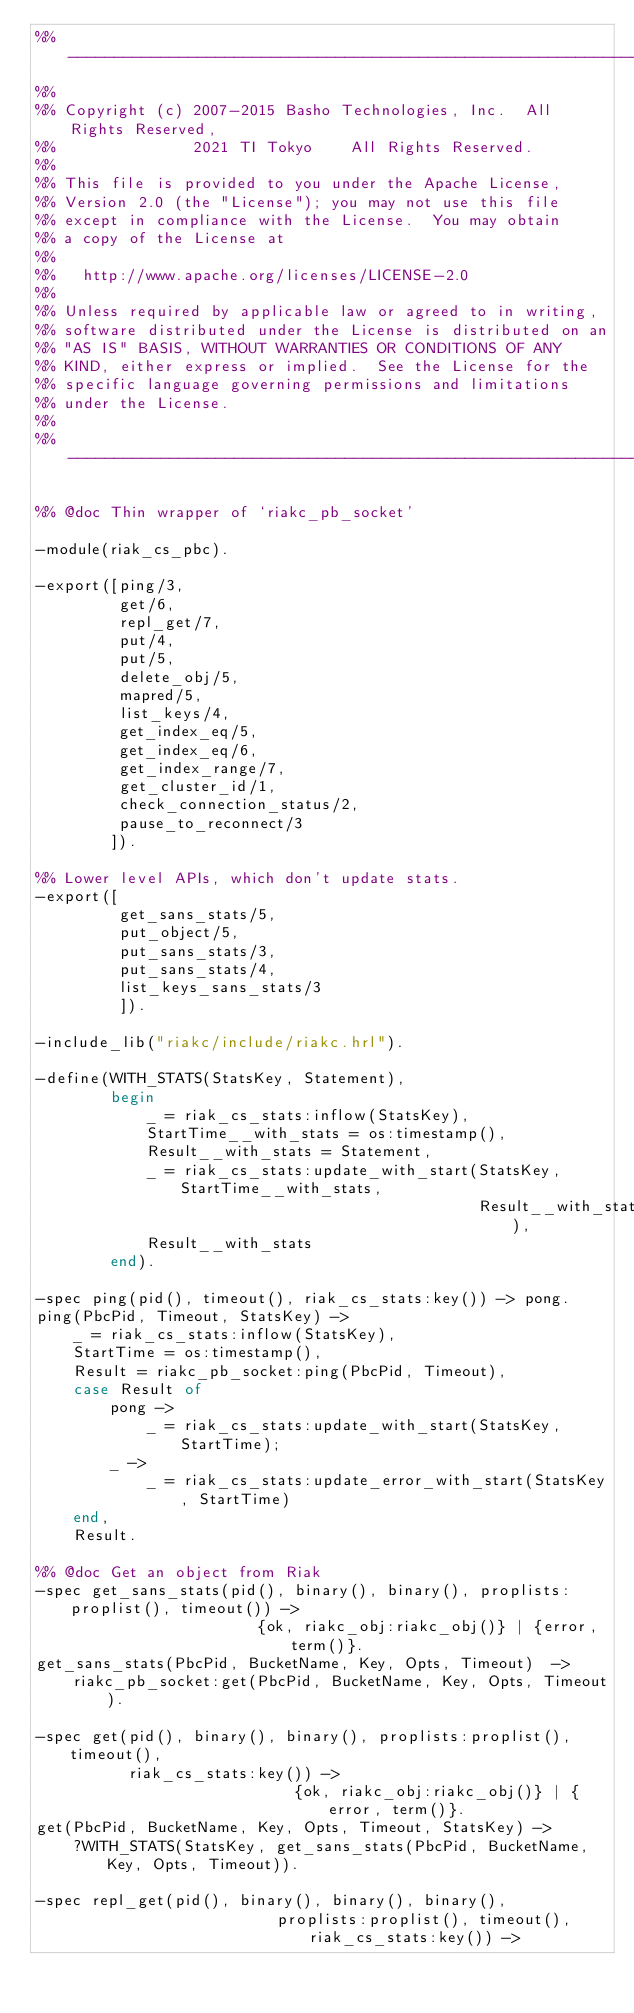Convert code to text. <code><loc_0><loc_0><loc_500><loc_500><_Erlang_>%% ---------------------------------------------------------------------
%%
%% Copyright (c) 2007-2015 Basho Technologies, Inc.  All Rights Reserved,
%%               2021 TI Tokyo    All Rights Reserved.
%%
%% This file is provided to you under the Apache License,
%% Version 2.0 (the "License"); you may not use this file
%% except in compliance with the License.  You may obtain
%% a copy of the License at
%%
%%   http://www.apache.org/licenses/LICENSE-2.0
%%
%% Unless required by applicable law or agreed to in writing,
%% software distributed under the License is distributed on an
%% "AS IS" BASIS, WITHOUT WARRANTIES OR CONDITIONS OF ANY
%% KIND, either express or implied.  See the License for the
%% specific language governing permissions and limitations
%% under the License.
%%
%% ---------------------------------------------------------------------

%% @doc Thin wrapper of `riakc_pb_socket'

-module(riak_cs_pbc).

-export([ping/3,
         get/6,
         repl_get/7,
         put/4,
         put/5,
         delete_obj/5,
         mapred/5,
         list_keys/4,
         get_index_eq/5,
         get_index_eq/6,
         get_index_range/7,
         get_cluster_id/1,
         check_connection_status/2,
         pause_to_reconnect/3
        ]).

%% Lower level APIs, which don't update stats.
-export([
         get_sans_stats/5,
         put_object/5,
         put_sans_stats/3,
         put_sans_stats/4,
         list_keys_sans_stats/3
         ]).

-include_lib("riakc/include/riakc.hrl").

-define(WITH_STATS(StatsKey, Statement),
        begin
            _ = riak_cs_stats:inflow(StatsKey),
            StartTime__with_stats = os:timestamp(),
            Result__with_stats = Statement,
            _ = riak_cs_stats:update_with_start(StatsKey, StartTime__with_stats,
                                                Result__with_stats),
            Result__with_stats
        end).

-spec ping(pid(), timeout(), riak_cs_stats:key()) -> pong.
ping(PbcPid, Timeout, StatsKey) ->
    _ = riak_cs_stats:inflow(StatsKey),
    StartTime = os:timestamp(),
    Result = riakc_pb_socket:ping(PbcPid, Timeout),
    case Result of
        pong ->
            _ = riak_cs_stats:update_with_start(StatsKey, StartTime);
        _ ->
            _ = riak_cs_stats:update_error_with_start(StatsKey, StartTime)
    end,
    Result.

%% @doc Get an object from Riak
-spec get_sans_stats(pid(), binary(), binary(), proplists:proplist(), timeout()) ->
                        {ok, riakc_obj:riakc_obj()} | {error, term()}.
get_sans_stats(PbcPid, BucketName, Key, Opts, Timeout)  ->
    riakc_pb_socket:get(PbcPid, BucketName, Key, Opts, Timeout).

-spec get(pid(), binary(), binary(), proplists:proplist(), timeout(),
          riak_cs_stats:key()) ->
                            {ok, riakc_obj:riakc_obj()} | {error, term()}.
get(PbcPid, BucketName, Key, Opts, Timeout, StatsKey) ->
    ?WITH_STATS(StatsKey, get_sans_stats(PbcPid, BucketName, Key, Opts, Timeout)).

-spec repl_get(pid(), binary(), binary(), binary(),
                          proplists:proplist(), timeout(), riak_cs_stats:key()) -></code> 